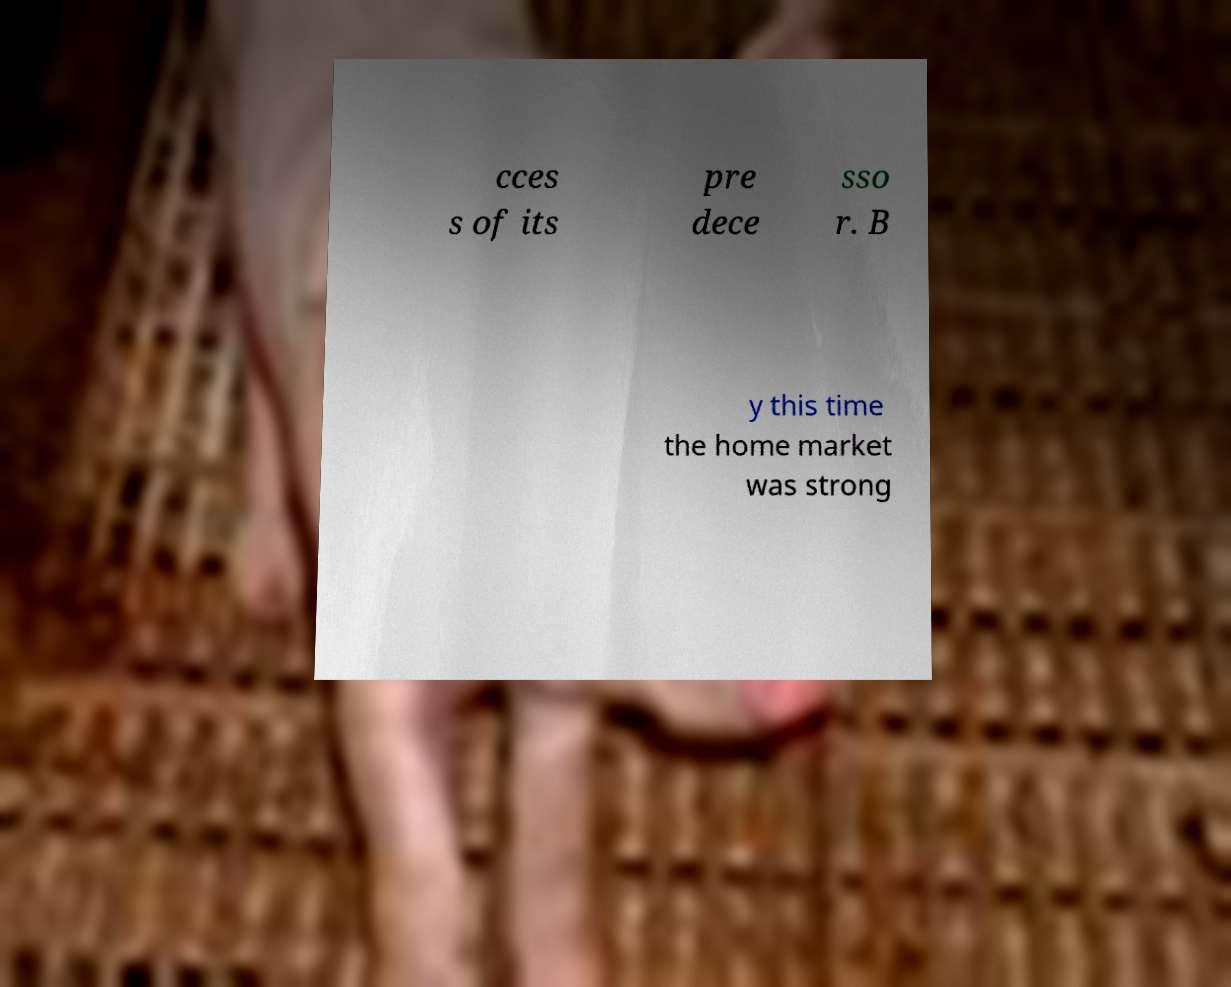Please read and relay the text visible in this image. What does it say? cces s of its pre dece sso r. B y this time the home market was strong 